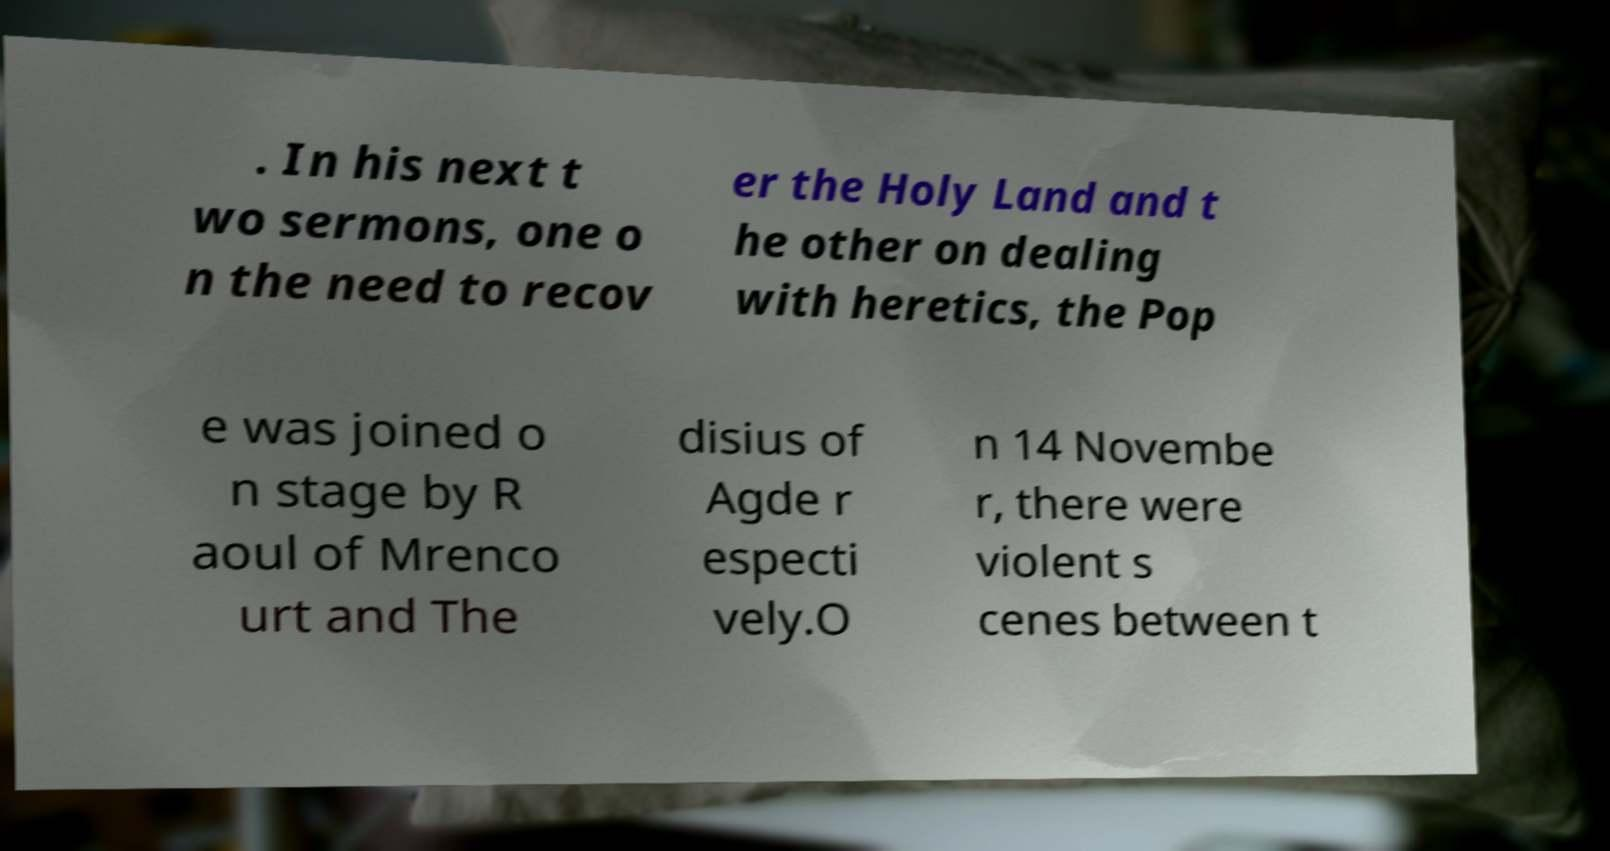Could you assist in decoding the text presented in this image and type it out clearly? . In his next t wo sermons, one o n the need to recov er the Holy Land and t he other on dealing with heretics, the Pop e was joined o n stage by R aoul of Mrenco urt and The disius of Agde r especti vely.O n 14 Novembe r, there were violent s cenes between t 